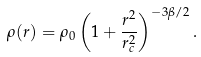Convert formula to latex. <formula><loc_0><loc_0><loc_500><loc_500>\rho ( r ) = \rho _ { 0 } \left ( 1 + \frac { r ^ { 2 } } { r _ { c } ^ { 2 } } \right ) ^ { - 3 \beta / 2 } .</formula> 